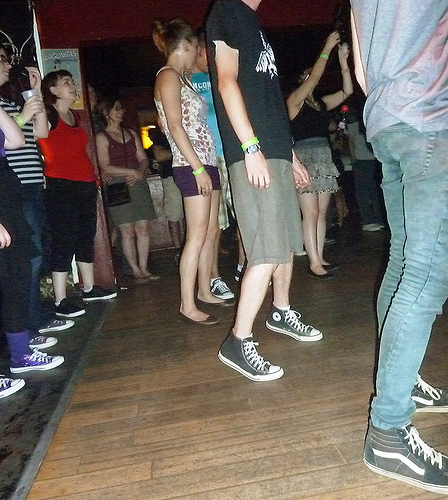<image>
Is there a woman on the dance floor? Yes. Looking at the image, I can see the woman is positioned on top of the dance floor, with the dance floor providing support. 